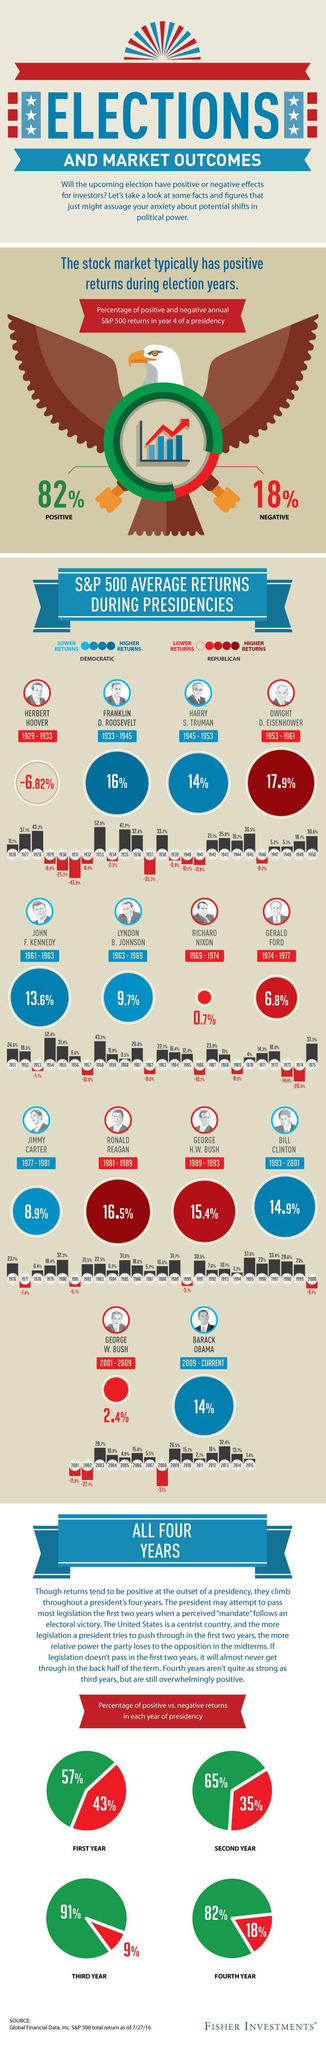What was the S&P 500 average returns when George H.W. Bush was the president?
Answer the question with a short phrase. 15.4% How many of the presidents shown in this infographic are Republicans? 7 The S&P 500 Average returns was 16.5% during whose Presidency? Ronald Reagan What was the S&P 500 average returns when Richard Nixon was the president? 0.7% What is the percentage of negative returns in the fourth year of presidency? 18% How many presidents are shown in this infographic? 14 What was the highest average returns percent among the Democratic Presidencies? 16% The highest average returns percentage was during which president's term? Dwight D. Eisenhower During whose presidency is a negative average returns percentage shown? Herbert Hoover What is the percentage of positive returns in the second year of presidency? 65% 